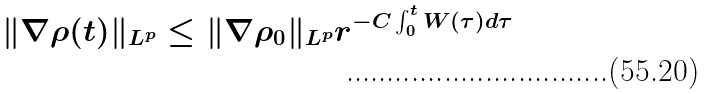<formula> <loc_0><loc_0><loc_500><loc_500>\| \nabla \rho ( t ) \| _ { L ^ { p } } \leq \| \nabla \rho _ { 0 } \| _ { L ^ { p } } r ^ { - C \int _ { 0 } ^ { t } W ( \tau ) d \tau }</formula> 